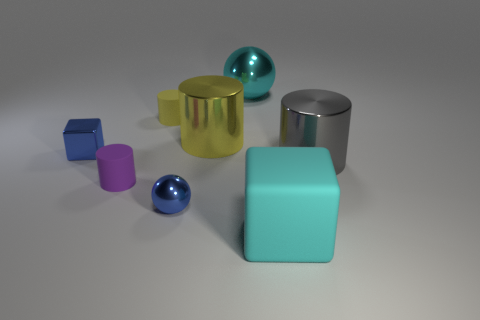There is a thing that is the same color as the rubber cube; what size is it?
Provide a succinct answer. Large. There is a purple cylinder; what number of rubber cubes are behind it?
Provide a short and direct response. 0. There is a gray metal cylinder on the right side of the yellow metallic thing to the right of the small yellow cylinder; what size is it?
Make the answer very short. Large. There is a big metallic object that is to the right of the cyan rubber block; is its shape the same as the small purple thing that is to the left of the small sphere?
Your response must be concise. Yes. What shape is the cyan object behind the cyan object that is right of the cyan ball?
Provide a short and direct response. Sphere. There is a matte thing that is left of the big yellow shiny cylinder and in front of the tiny yellow thing; what is its size?
Your response must be concise. Small. There is a cyan rubber object; is its shape the same as the blue shiny thing that is to the left of the purple object?
Offer a terse response. Yes. What size is the yellow metal object that is the same shape as the gray thing?
Provide a succinct answer. Large. There is a big cube; does it have the same color as the metallic cube that is to the left of the tiny purple thing?
Your answer should be very brief. No. What number of other things are the same size as the yellow rubber cylinder?
Your answer should be compact. 3. 